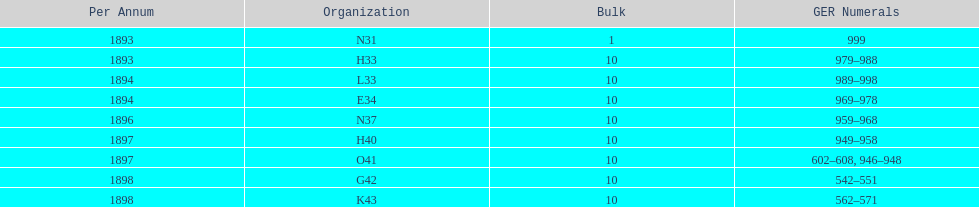Was the quantity higher in 1894 or 1893? 1894. 